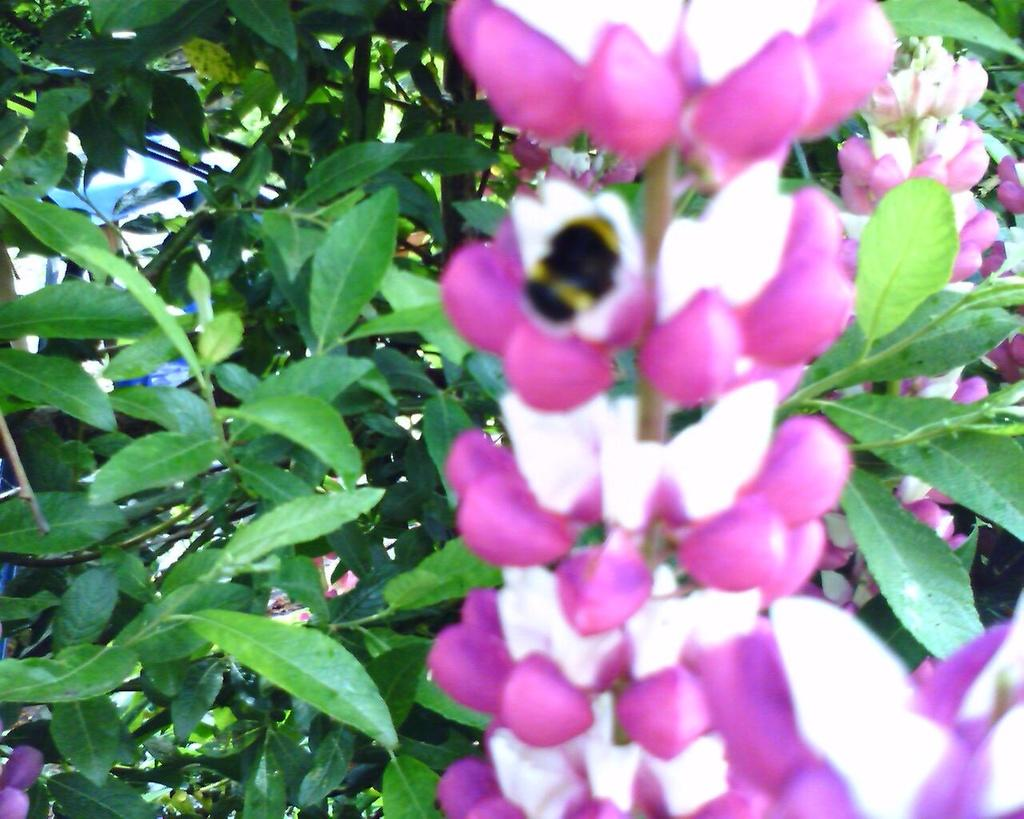What type of flowers can be seen in the image? There are pink flowers in the image. What do the flowers belong to? The flowers belong to a plant. What can be seen in the background of the image? There are trees in the background of the image. What color are the leaves of the trees? The leaves of the trees are green. What type of cloth is used to cover the box in the image? There is no box or cloth present in the image; it only features pink flowers and trees in the background. 